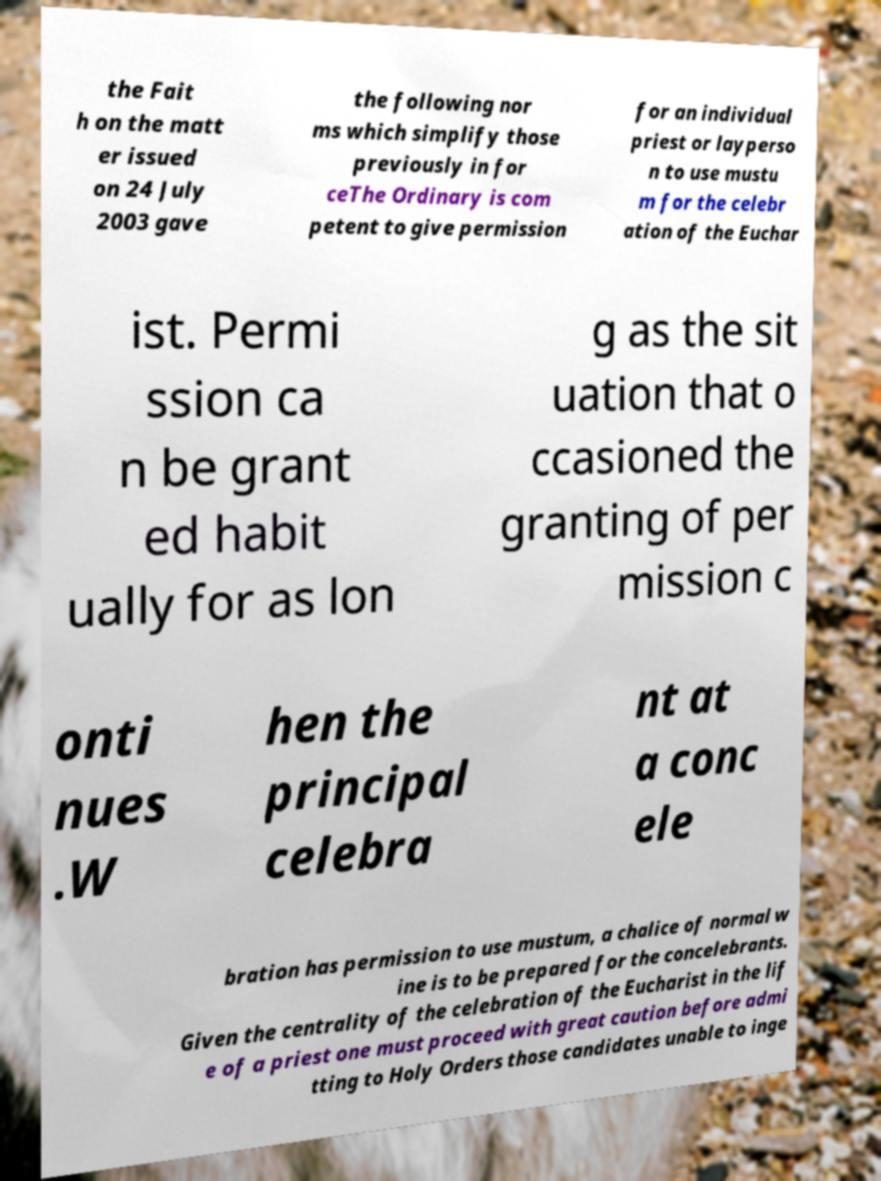Please read and relay the text visible in this image. What does it say? the Fait h on the matt er issued on 24 July 2003 gave the following nor ms which simplify those previously in for ceThe Ordinary is com petent to give permission for an individual priest or layperso n to use mustu m for the celebr ation of the Euchar ist. Permi ssion ca n be grant ed habit ually for as lon g as the sit uation that o ccasioned the granting of per mission c onti nues .W hen the principal celebra nt at a conc ele bration has permission to use mustum, a chalice of normal w ine is to be prepared for the concelebrants. Given the centrality of the celebration of the Eucharist in the lif e of a priest one must proceed with great caution before admi tting to Holy Orders those candidates unable to inge 